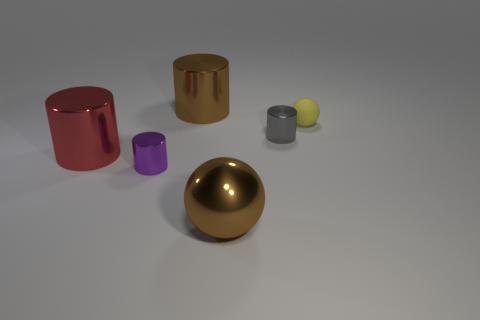Is there anything else that has the same material as the tiny yellow thing?
Keep it short and to the point. No. Is the material of the large red object the same as the big brown ball?
Your answer should be compact. Yes. There is a sphere that is the same size as the brown cylinder; what color is it?
Ensure brevity in your answer.  Brown. The object that is both to the right of the large brown metallic cylinder and behind the gray metal object is what color?
Keep it short and to the point. Yellow. There is a thing that is the same color as the big sphere; what is its shape?
Ensure brevity in your answer.  Cylinder. There is a cylinder that is on the right side of the large brown thing that is on the right side of the large shiny cylinder behind the red metallic thing; what size is it?
Ensure brevity in your answer.  Small. What is the purple cylinder made of?
Keep it short and to the point. Metal. Do the purple cylinder and the sphere behind the big red metal cylinder have the same material?
Give a very brief answer. No. Are there any other things that are the same color as the big metal ball?
Provide a short and direct response. Yes. There is a tiny object that is right of the metallic cylinder that is to the right of the big metallic sphere; is there a tiny purple metallic thing that is left of it?
Give a very brief answer. Yes. 